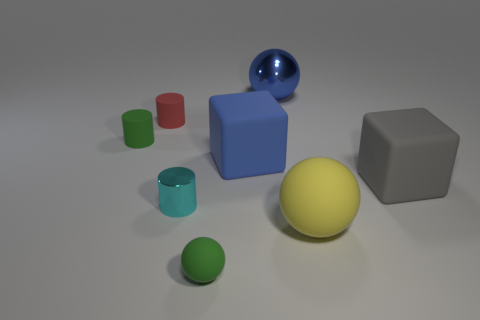How many objects are either cyan cylinders or rubber objects?
Provide a succinct answer. 7. There is a rubber thing that is to the left of the big blue cube and on the right side of the tiny red rubber thing; what is its shape?
Provide a short and direct response. Sphere. There is a small cyan metallic object; is its shape the same as the green matte thing to the left of the red cylinder?
Offer a terse response. Yes. There is a gray object; are there any tiny red cylinders in front of it?
Give a very brief answer. No. There is a object that is the same color as the small rubber sphere; what is it made of?
Provide a succinct answer. Rubber. How many spheres are either matte things or small cyan things?
Offer a very short reply. 2. Does the blue metallic thing have the same shape as the tiny cyan shiny object?
Your answer should be very brief. No. What size is the matte ball that is right of the large blue shiny ball?
Ensure brevity in your answer.  Large. Is there a big block that has the same color as the metal ball?
Your answer should be very brief. Yes. Do the block that is to the right of the blue ball and the tiny red rubber cylinder have the same size?
Your answer should be very brief. No. 